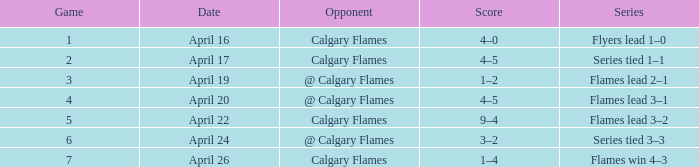Which series involves a rival of calgary flames, with a scoreline of 9-4? Flames lead 3–2. 